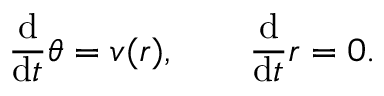Convert formula to latex. <formula><loc_0><loc_0><loc_500><loc_500>\frac { d } { d t } \theta = v ( r ) , \quad \frac { d } { d t } r = 0 .</formula> 